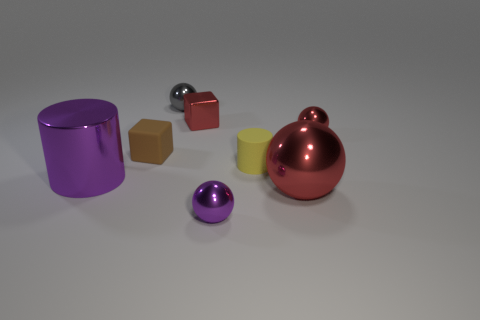Add 2 yellow metal things. How many objects exist? 10 Subtract all cubes. How many objects are left? 6 Subtract 0 yellow cubes. How many objects are left? 8 Subtract all tiny gray metallic balls. Subtract all shiny objects. How many objects are left? 1 Add 3 big metallic balls. How many big metallic balls are left? 4 Add 8 tiny blue shiny balls. How many tiny blue shiny balls exist? 8 